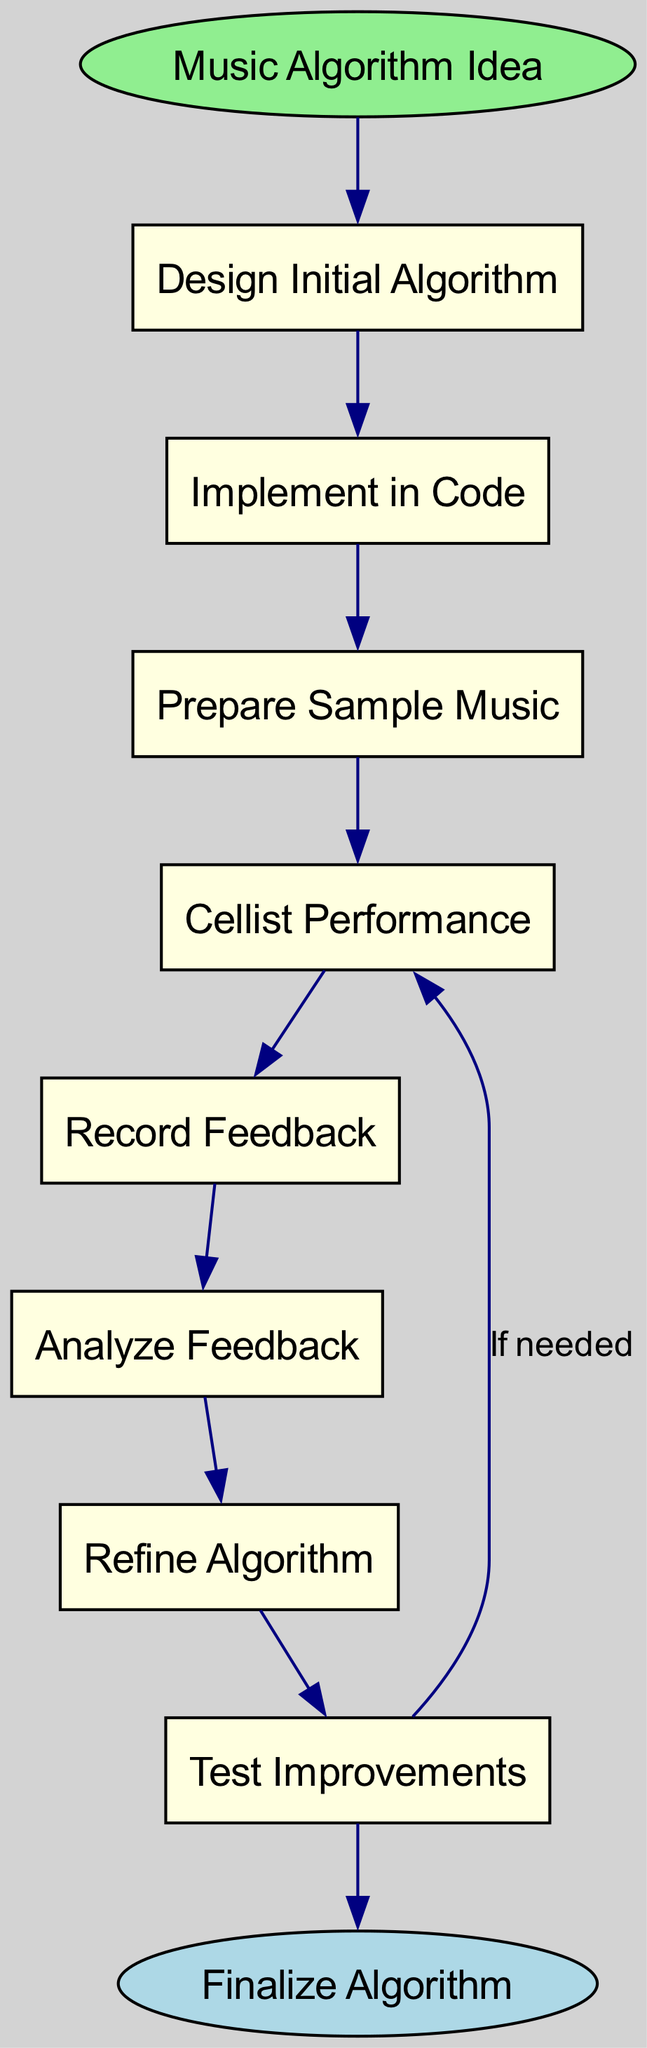What is the first step in the algorithm development process? The diagram starts with the node "Music Algorithm Idea," which is labeled as the initial step before any development begins.
Answer: Music Algorithm Idea How many nodes are present in the diagram? By counting all the nodes listed, including the start and end nodes, we identify a total of 9 nodes in the diagram.
Answer: 9 What connects "Record Feedback" to the next step? The arrow from "Record Feedback" leads to "Analyze Feedback," indicating that the output of recording feedback is the analysis of that feedback.
Answer: Analyze Feedback Which node follows "Refine Algorithm"? The diagram shows that after "Refine Algorithm," the next node to follow is "Test Improvements," demonstrating its sequential relation in the process.
Answer: Test Improvements What is the purpose of the edge labeled "If needed"? The edge indicates that if further improvements are necessary after testing, the process will loop back to "Cellist Performance" for additional feedback, suggesting an iterative refinement phase.
Answer: Iterative feedback What is the end node of the algorithm development process? The diagram concludes at the node labeled "Finalize Algorithm," representing the end of the algorithm development journey after incorporating feedback.
Answer: Finalize Algorithm How do "Test Improvements" and "Cellist Performance" interact within the flow? The arrow labeled "If needed" shows that "Test Improvements" creates a conditional flow back to "Cellist Performance," indicating a loop for further adjustments based on testing outcomes.
Answer: Conditioned feedback loop What step comes directly before "Cellist Performance"? The step that occurs directly prior to "Cellist Performance" is "Prepare Sample Music," which indicates that music must be prepared for the cellist to perform.
Answer: Prepare Sample Music 